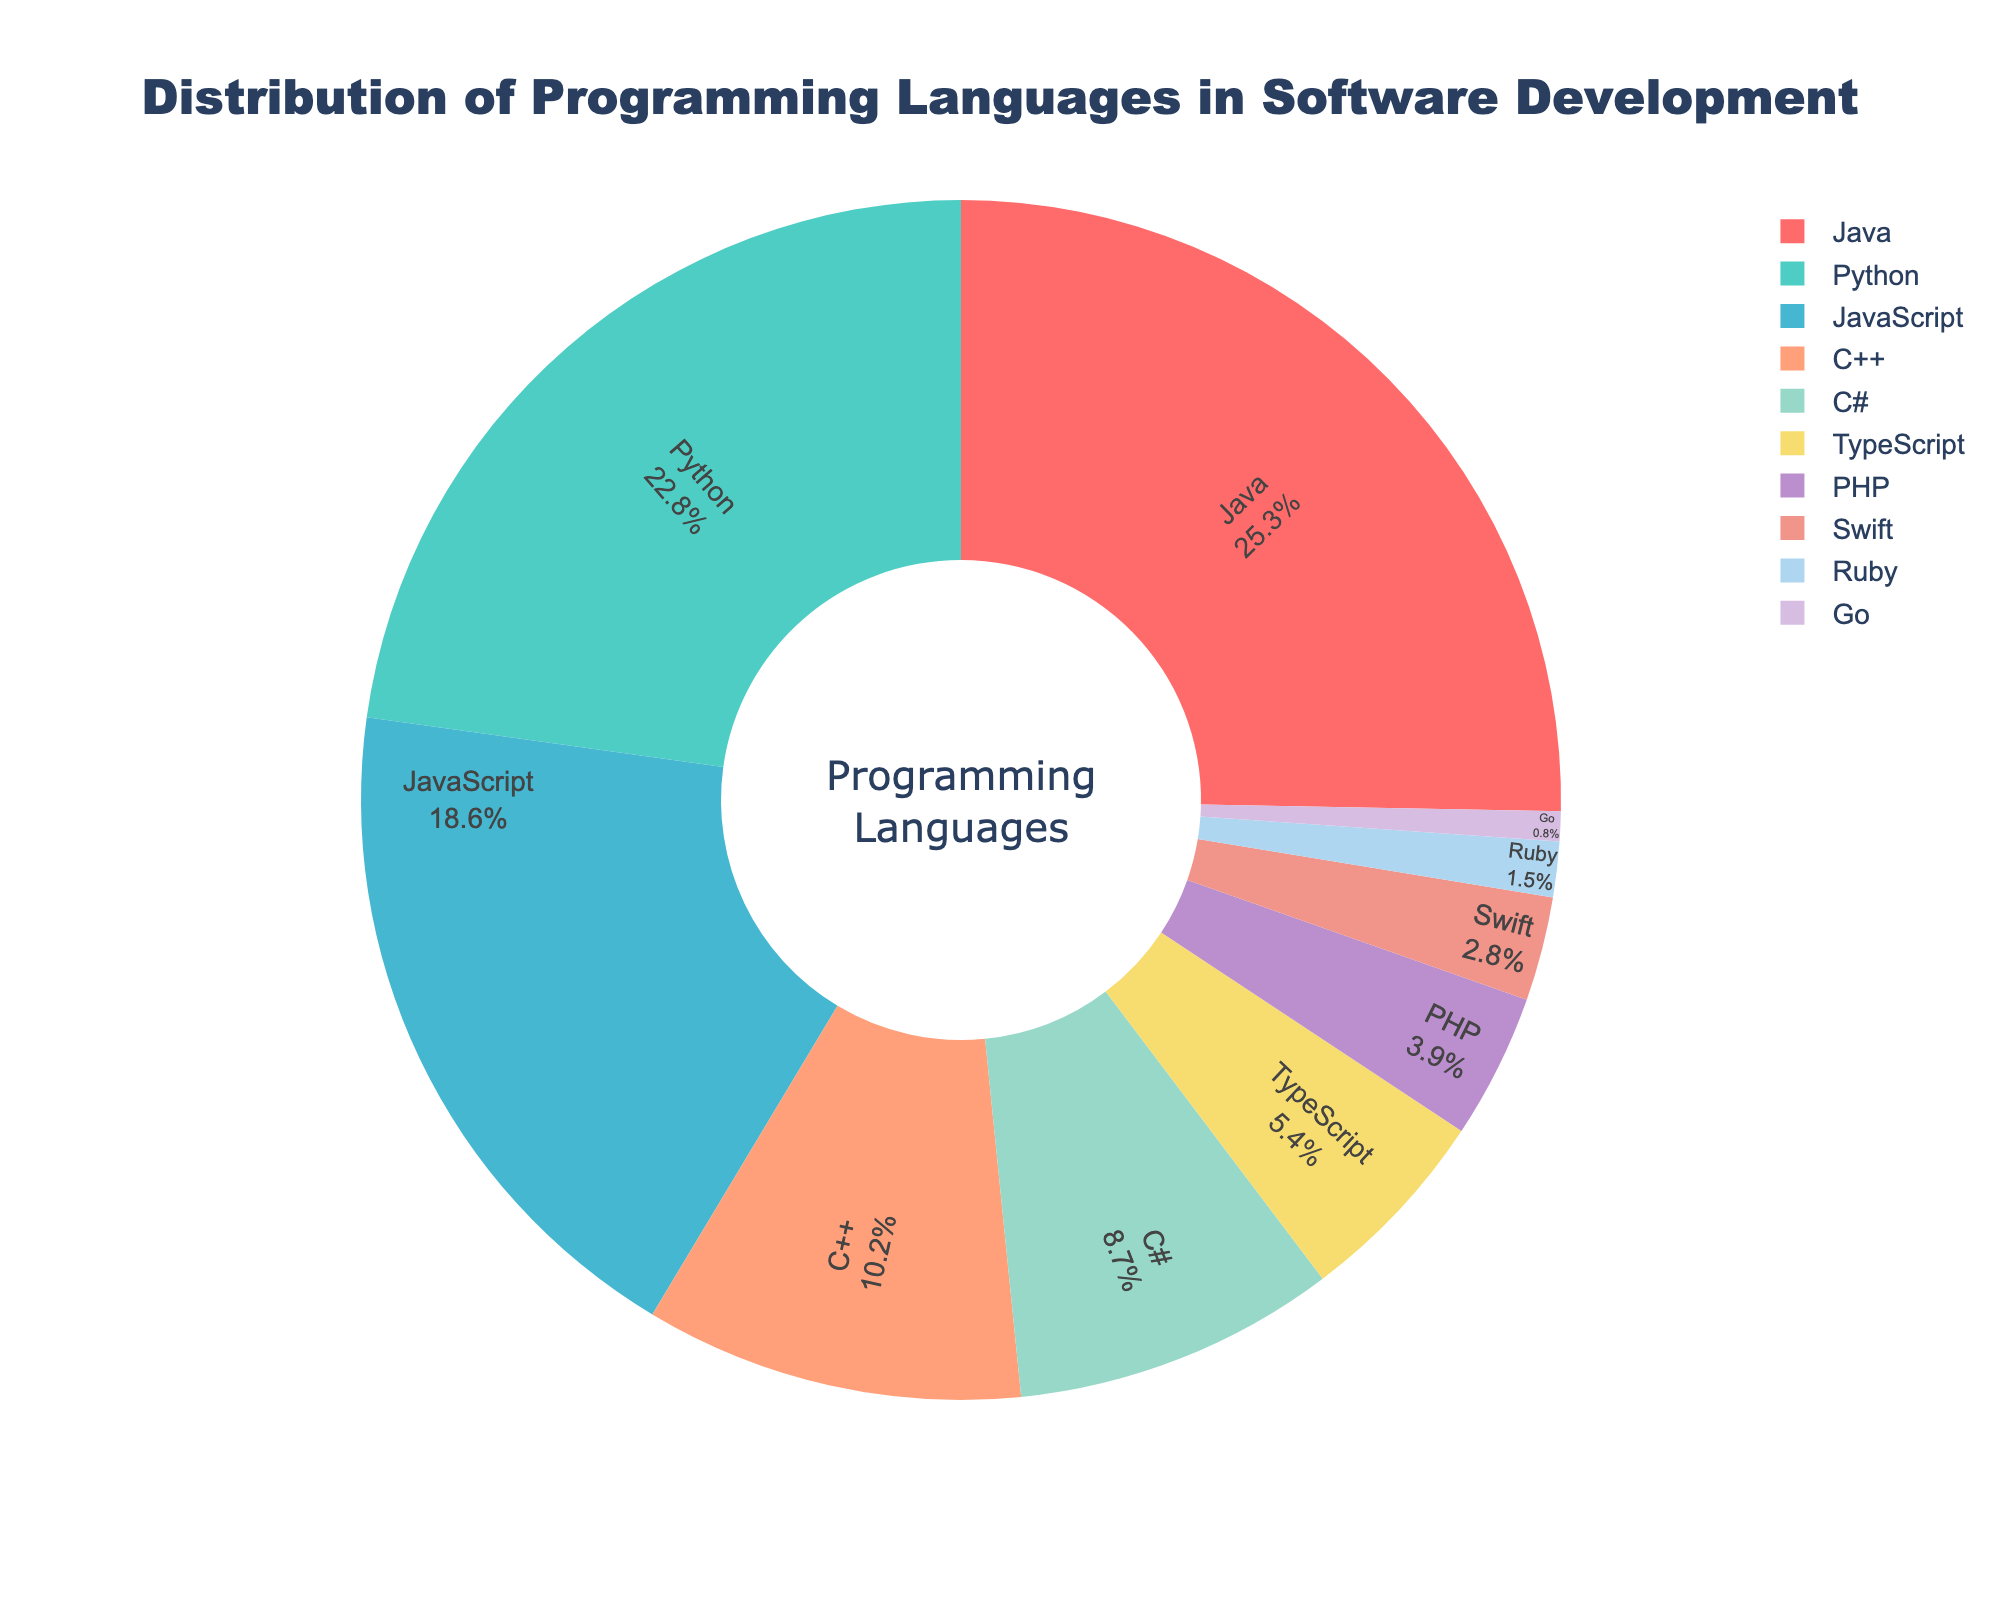What's the most used programming language in the pie chart? The largest section in the pie chart represents Java, indicating it has the highest percentage.
Answer: Java Which programming languages have a combined percentage greater than 40%? Adding Java (25.3%) and Python (22.8%), we get 48.1%. Therefore, any combination involving Java and Python fits this criterion. JavaScript adds another 18.6%, making the combined percentage even larger.
Answer: Java, Python How much more popular is Java compared to C++? Java has a percentage of 25.3%, and C++ has 10.2%. Subtract the percentage of C++ from Java: 25.3% - 10.2% = 15.1%.
Answer: 15.1% What is the total percentage of C# and TypeScript combined? Add the percentage of C# (8.7%) and TypeScript (5.4%): 8.7% + 5.4% = 14.1%.
Answer: 14.1% Which two programming languages have the smallest combined percentage? Ruby has 1.5% and Go has 0.8%. Add their percentages: 1.5% + 0.8% = 2.3%, which is the smallest sum.
Answer: Ruby and Go What is the average percentage of Python, JavaScript, and PHP? Add the percentages of Python (22.8%), JavaScript (18.6%), and PHP (3.9%): 22.8% + 18.6% + 3.9% = 45.3%. Divide by 3 to get the average: 45.3% / 3 ≈ 15.1%.
Answer: 15.1% What is the difference in the percentage between the most and least used programming languages? The most used language is Java (25.3%), and the least used is Go (0.8%). Subtract Go's percentage from Java's: 25.3% - 0.8% = 24.5%.
Answer: 24.5% Which language is represented by the green color? By the color assignment given in the code, the green section corresponds to Python, which is the second largest section.
Answer: Python Which languages have a combined percentage lower than that of Java? Python (22.8%) is the only language close to Java individually, but adding JavaScript (18.6%) and more only exceeds Java's percentage. Therefore, combinations like C++ (10.2%) + C# (8.7%) + TypeScript (5.4%) = 24.3% or C++ + PHP (3.9%) + Swift (2.8%) = 16.9% meet this criteria.
Answer: C++, C#, TypeScript What percentage of the total do all the languages except Java and Python represent? Subtract the percentages of Java (25.3%) and Python (22.8%) from 100%: 100% - 25.3% - 22.8% = 51.9%.
Answer: 51.9% 